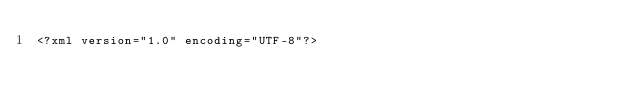Convert code to text. <code><loc_0><loc_0><loc_500><loc_500><_XML_><?xml version="1.0" encoding="UTF-8"?></code> 